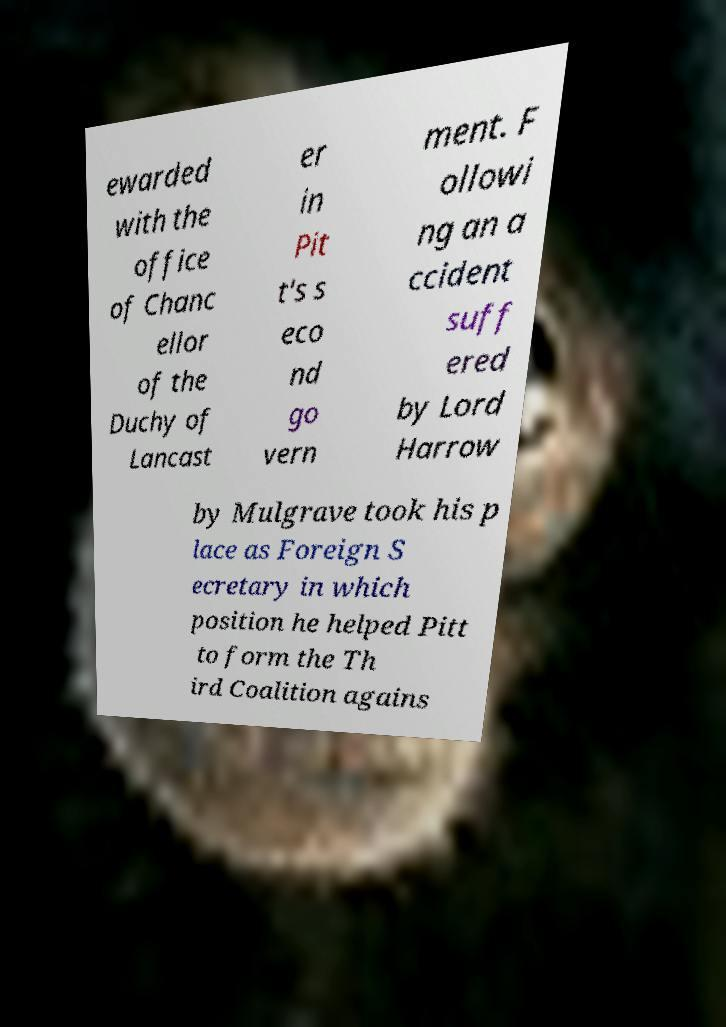What messages or text are displayed in this image? I need them in a readable, typed format. ewarded with the office of Chanc ellor of the Duchy of Lancast er in Pit t's s eco nd go vern ment. F ollowi ng an a ccident suff ered by Lord Harrow by Mulgrave took his p lace as Foreign S ecretary in which position he helped Pitt to form the Th ird Coalition agains 